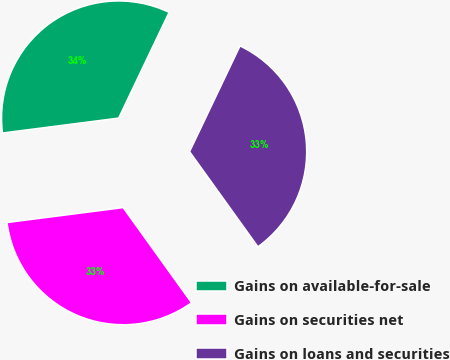Convert chart to OTSL. <chart><loc_0><loc_0><loc_500><loc_500><pie_chart><fcel>Gains on available-for-sale<fcel>Gains on securities net<fcel>Gains on loans and securities<nl><fcel>34.12%<fcel>32.88%<fcel>33.0%<nl></chart> 